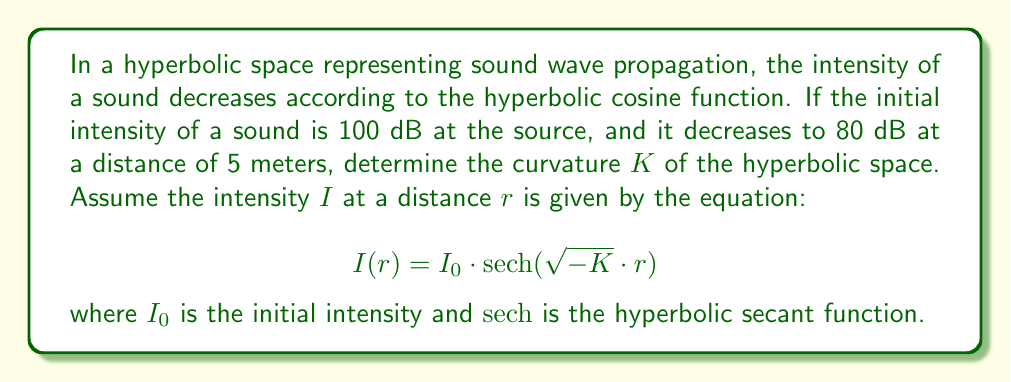Give your solution to this math problem. To solve this problem, we'll follow these steps:

1) First, let's write out our known values:
   $I_0 = 100$ dB (initial intensity)
   $I(5) = 80$ dB (intensity at 5 meters)
   $r = 5$ meters

2) We can substitute these into our equation:

   $$80 = 100 \cdot \text{sech}(\sqrt{-K} \cdot 5)$$

3) Divide both sides by 100:

   $$0.8 = \text{sech}(\sqrt{-K} \cdot 5)$$

4) Take the arcsech (inverse hyperbolic secant) of both sides:

   $$\text{arcsech}(0.8) = \sqrt{-K} \cdot 5$$

5) Divide both sides by 5:

   $$\frac{\text{arcsech}(0.8)}{5} = \sqrt{-K}$$

6) Square both sides:

   $$\left(\frac{\text{arcsech}(0.8)}{5}\right)^2 = -K$$

7) Take the negative of both sides:

   $$K = -\left(\frac{\text{arcsech}(0.8)}{5}\right)^2$$

8) Calculate the value (you can use a calculator for this):

   $$K \approx -0.00202616$$

This negative value indicates that the space is indeed hyperbolic, as expected.
Answer: $K \approx -0.00202616 \text{ m}^{-2}$ 